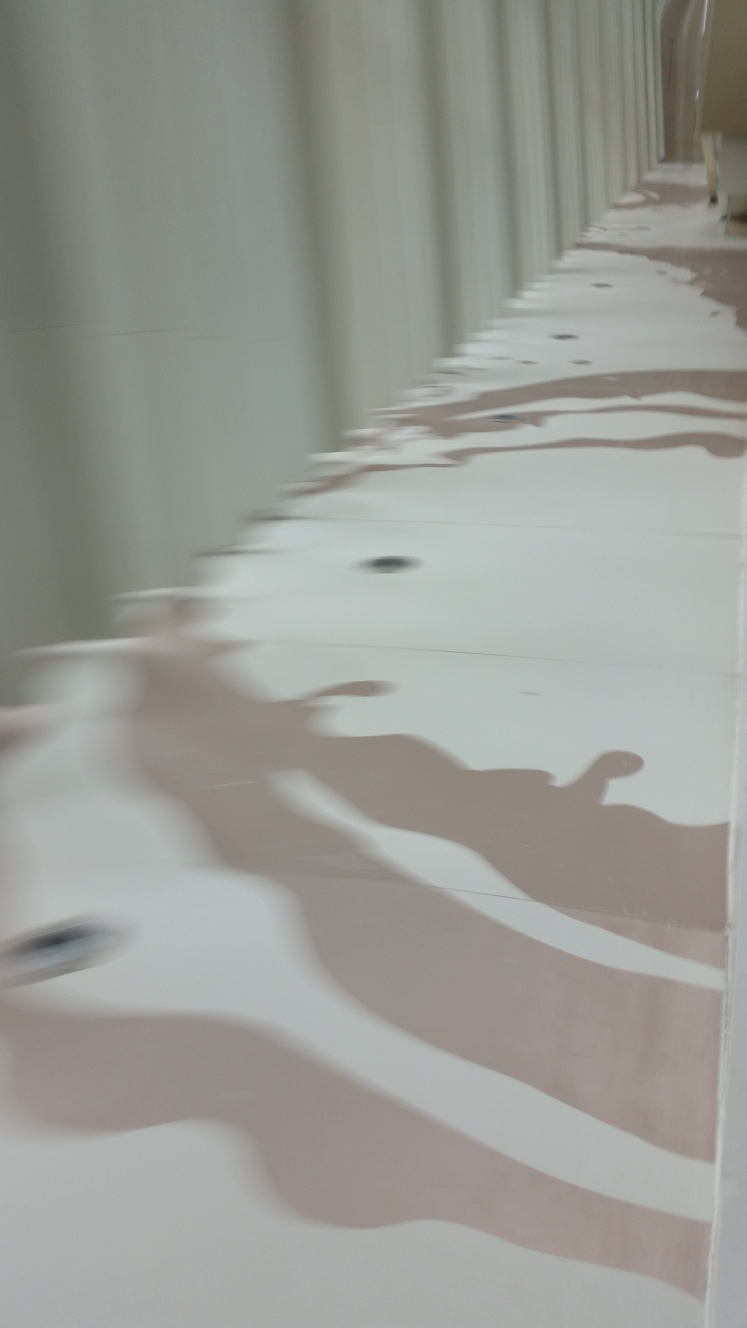Is there anything about this image that seems unique or particularly notable? The image is unique in its composition, presenting a repeated pattern of reflections that create an abstract and artistic visual effect. The perspective is slightly tilted, which could be a creative choice to emphasize the pattern's flow. The size and repetition of the forms along the space suggest a large-scale installation, which is notable for its potential to influence the ambiance of the setting. What feelings or ideas might this image evoke in a viewer? The fluid pattern evokes a sense of motion and continuity, which might instill feelings of calmness or introspection. For others, it may inspire creativity or a desire for exploration, as it doesn't immediately reveal its purpose or context. The abstraction allows for personal interpretation, inviting viewers to engage with the image in a way that resonates with their own experiences or emotions. 